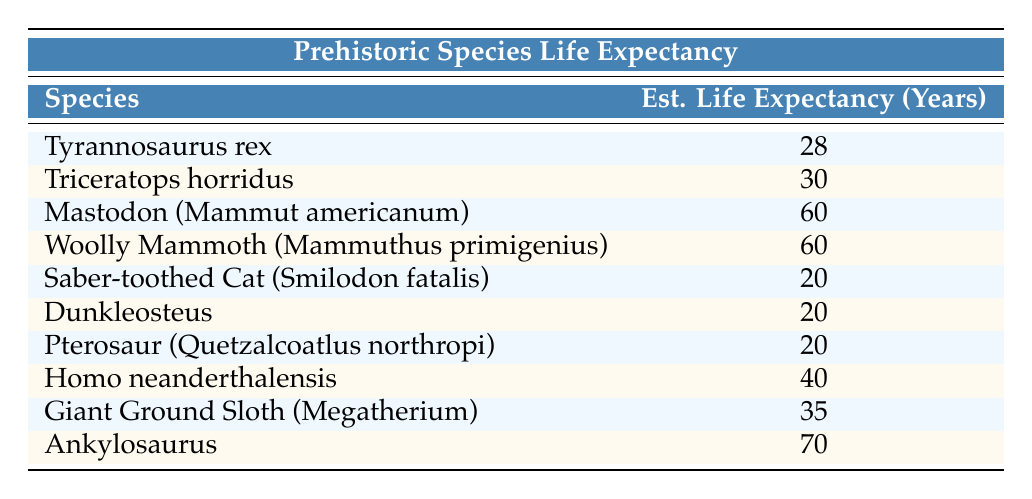What is the estimated life expectancy of Tyrannosaurus rex? The table lists the estimated life expectancy of Tyrannosaurus rex as 28 years.
Answer: 28 years Which species has the longest estimated life expectancy? According to the table, Ankylosaurus has the longest estimated life expectancy, listed as 70 years.
Answer: Ankylosaurus How many species have an estimated life expectancy of 20 years? The table shows that Saber-toothed Cat, Dunkleosteus, and Pterosaur each have an estimated life expectancy of 20 years, totaling three species.
Answer: 3 species What is the average life expectancy of the species listed in the table? To find the average, first sum the life expectancy values: (28 + 30 + 60 + 60 + 20 + 20 + 20 + 40 + 35 + 70) =  443. Then divide by the number of species (10): 443/10 = 44.3.
Answer: 44.3 years Is it true that Homo neanderthalensis has a longer estimated life expectancy than both Saber-toothed Cat and Dunkleosteus? The life expectancy of Homo neanderthalensis is 40 years, while Saber-toothed Cat and Dunkleosteus have 20 years each, making the statement true.
Answer: Yes Which species has a higher life expectancy: Triceratops horridus or Giant Ground Sloth? Triceratops horridus has an estimated life expectancy of 30 years, while Giant Ground Sloth has 35 years; thus, Giant Ground Sloth has a higher life expectancy.
Answer: Giant Ground Sloth What is the difference in life expectancy between Mastodon and Woolly Mammoth? Both Mastodon and Woolly Mammoth have an estimated life expectancy of 60 years. Therefore, the difference in life expectancy is 0 years.
Answer: 0 years How many species have a life expectancy of 40 years or more? The table indicates that Mastodon, Woolly Mammoth, Homo neanderthalensis, Giant Ground Sloth, and Ankylosaurus have life expectancies of 40 years or more, totaling five species.
Answer: 5 species Which two species have the shortest life expectancies combined? Saber-toothed Cat (20 years) and Dunkleosteus (20 years) both share the shortest life expectancy, with a combined total of 40 years.
Answer: 40 years 